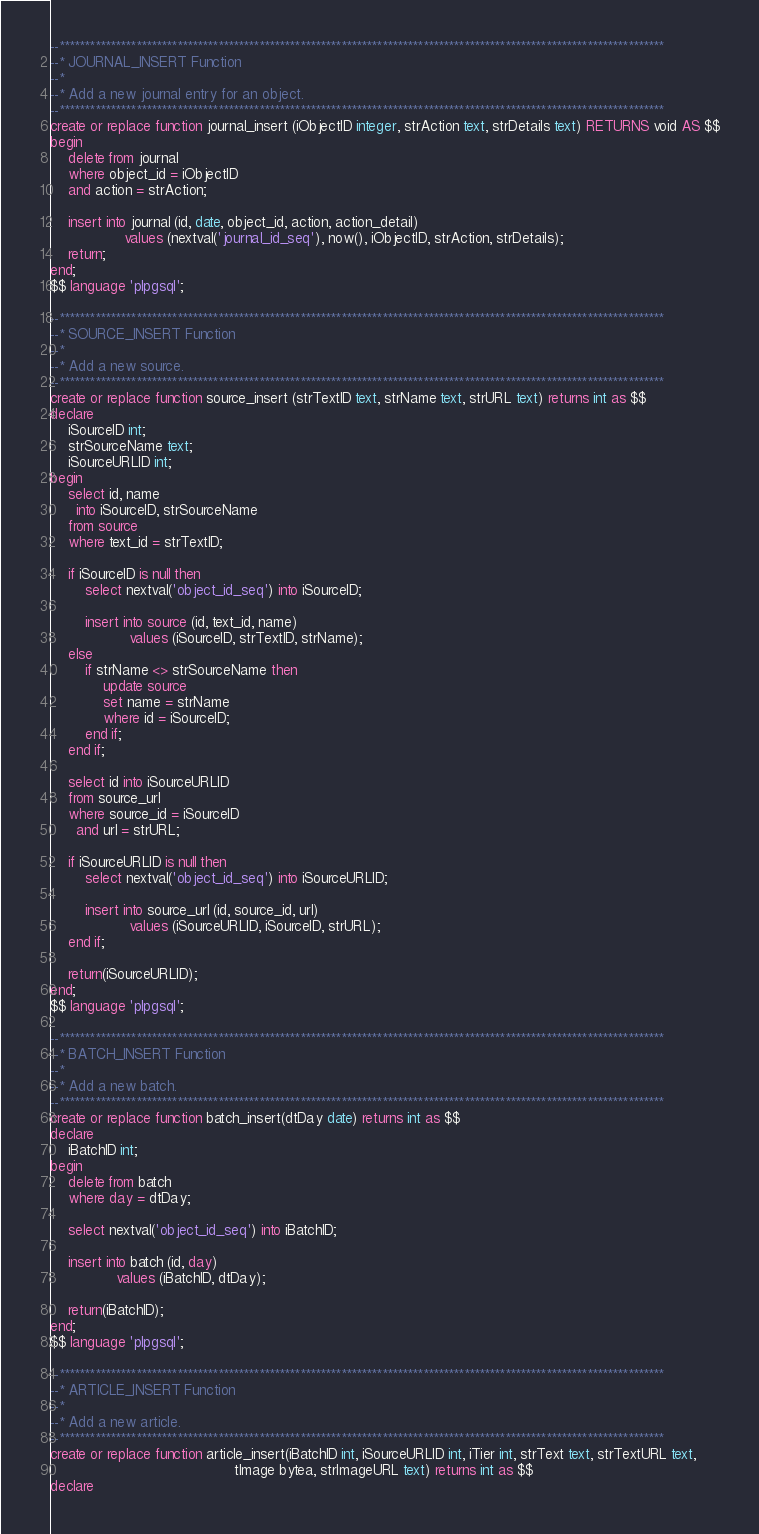Convert code to text. <code><loc_0><loc_0><loc_500><loc_500><_SQL_>--**********************************************************************************************************************
--* JOURNAL_INSERT Function
--* 
--* Add a new journal entry for an object.
--**********************************************************************************************************************
create or replace function journal_insert (iObjectID integer, strAction text, strDetails text) RETURNS void AS $$
begin
    delete from journal
    where object_id = iObjectID
    and action = strAction;

    insert into journal (id, date, object_id, action, action_detail) 
                 values (nextval('journal_id_seq'), now(), iObjectID, strAction, strDetails);  
    return;
end;
$$ language 'plpgsql';

--**********************************************************************************************************************
--* SOURCE_INSERT Function
--* 
--* Add a new source.
--**********************************************************************************************************************
create or replace function source_insert (strTextID text, strName text, strURL text) returns int as $$
declare
    iSourceID int;
    strSourceName text;
    iSourceURLID int;
begin
    select id, name 
      into iSourceID, strSourceName
    from source
    where text_id = strTextID;

    if iSourceID is null then
        select nextval('object_id_seq') into iSourceID;

        insert into source (id, text_id, name)
                  values (iSourceID, strTextID, strName);
    else
        if strName <> strSourceName then
            update source
            set name = strName
            where id = iSourceID;
        end if;
    end if;

    select id into iSourceURLID
    from source_url
    where source_id = iSourceID
      and url = strURL;

    if iSourceURLID is null then
        select nextval('object_id_seq') into iSourceURLID;

        insert into source_url (id, source_id, url)
                  values (iSourceURLID, iSourceID, strURL);
    end if;

    return(iSourceURLID);
end;
$$ language 'plpgsql';

--**********************************************************************************************************************
--* BATCH_INSERT Function
--* 
--* Add a new batch.
--**********************************************************************************************************************
create or replace function batch_insert(dtDay date) returns int as $$
declare
    iBatchID int;
begin
    delete from batch
    where day = dtDay;

    select nextval('object_id_seq') into iBatchID;

    insert into batch (id, day)
               values (iBatchID, dtDay);

    return(iBatchID);
end;
$$ language 'plpgsql';

--**********************************************************************************************************************
--* ARTICLE_INSERT Function
--* 
--* Add a new article.
--**********************************************************************************************************************
create or replace function article_insert(iBatchID int, iSourceURLID int, iTier int, strText text, strTextURL text, 
                                          tImage bytea, strImageURL text) returns int as $$
declare</code> 